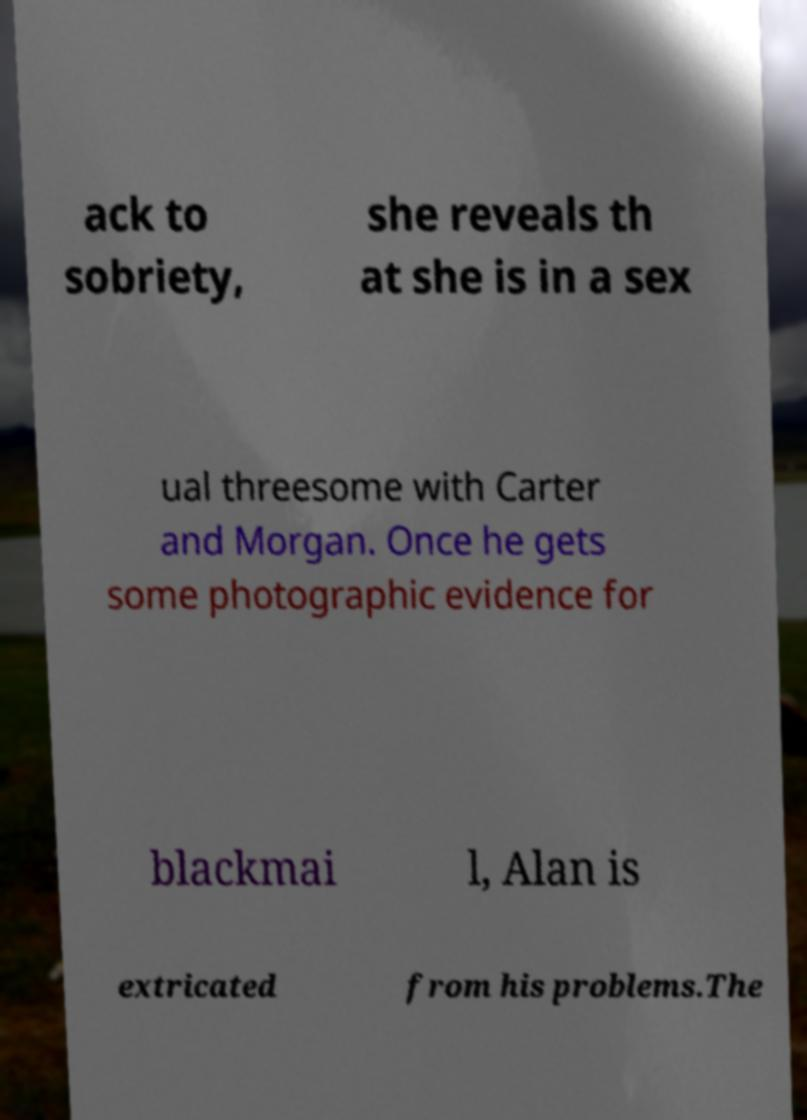There's text embedded in this image that I need extracted. Can you transcribe it verbatim? ack to sobriety, she reveals th at she is in a sex ual threesome with Carter and Morgan. Once he gets some photographic evidence for blackmai l, Alan is extricated from his problems.The 